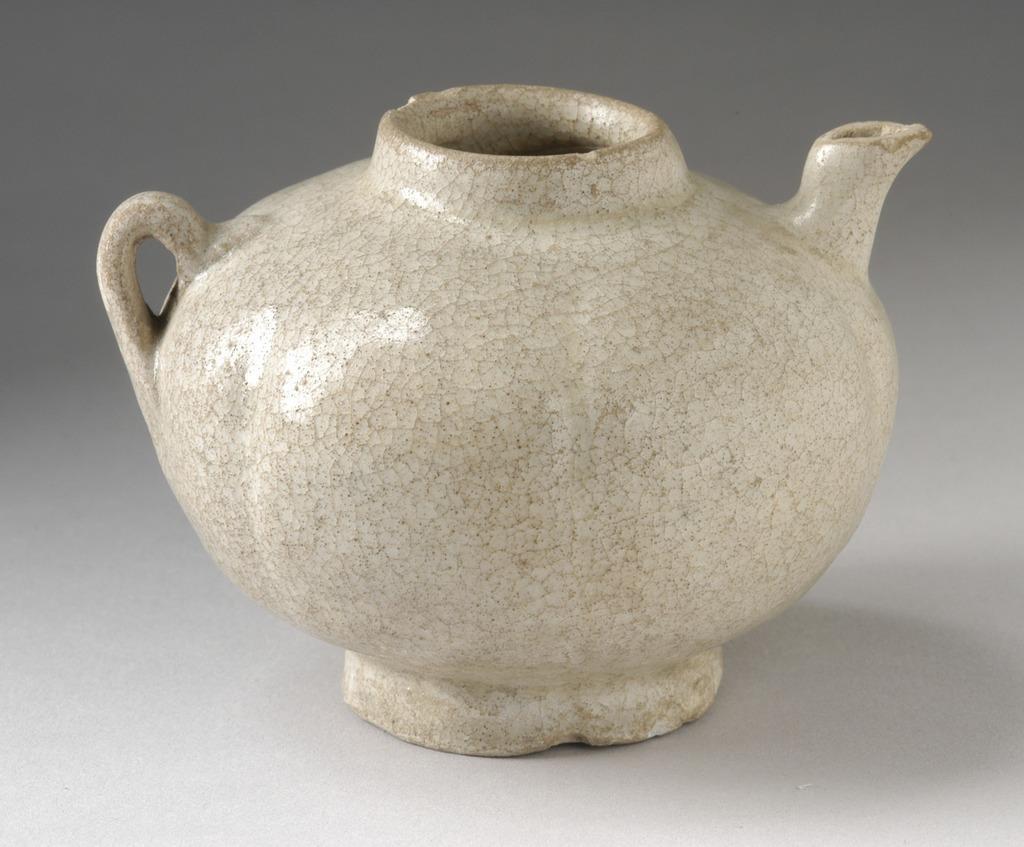Please provide a concise description of this image. In this image in the center there is one pot, and at the bottom there is white color table. 